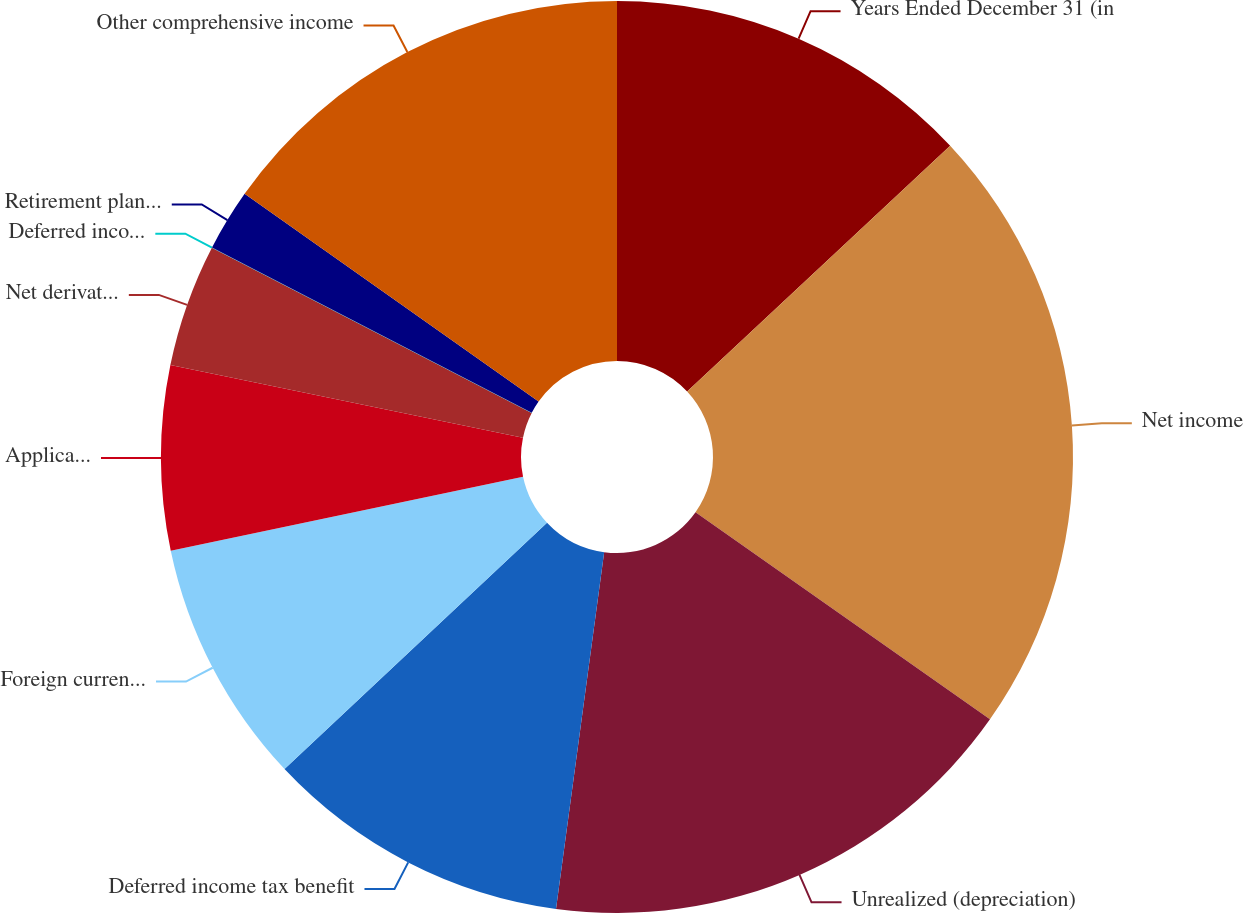<chart> <loc_0><loc_0><loc_500><loc_500><pie_chart><fcel>Years Ended December 31 (in<fcel>Net income<fcel>Unrealized (depreciation)<fcel>Deferred income tax benefit<fcel>Foreign currency translation<fcel>Applicable income tax benefit<fcel>Net derivative gains arising<fcel>Deferred income tax expense on<fcel>Retirement plan liabilities<fcel>Other comprehensive income<nl><fcel>13.04%<fcel>21.72%<fcel>17.38%<fcel>10.87%<fcel>8.7%<fcel>6.53%<fcel>4.36%<fcel>0.01%<fcel>2.19%<fcel>15.21%<nl></chart> 